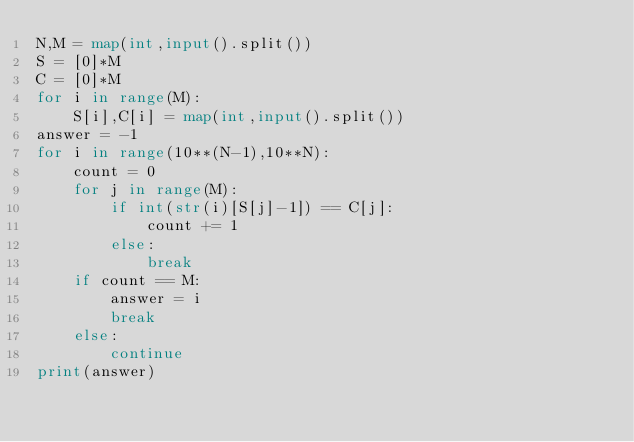<code> <loc_0><loc_0><loc_500><loc_500><_Python_>N,M = map(int,input().split())
S = [0]*M
C = [0]*M
for i in range(M):
    S[i],C[i] = map(int,input().split())
answer = -1
for i in range(10**(N-1),10**N):
    count = 0
    for j in range(M):
        if int(str(i)[S[j]-1]) == C[j]:
            count += 1
        else:
            break
    if count == M:
        answer = i
        break
    else:
        continue
print(answer)</code> 